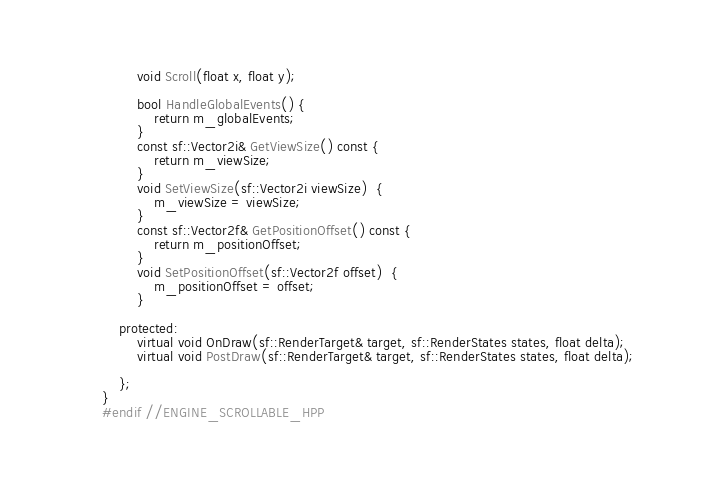<code> <loc_0><loc_0><loc_500><loc_500><_C++_>
		void Scroll(float x, float y);

		bool HandleGlobalEvents() {
			return m_globalEvents;
		}
		const sf::Vector2i& GetViewSize() const {
			return m_viewSize;
		}
		void SetViewSize(sf::Vector2i viewSize)  {
			m_viewSize = viewSize;
		}
		const sf::Vector2f& GetPositionOffset() const {
			return m_positionOffset;
		}
		void SetPositionOffset(sf::Vector2f offset)  {
			m_positionOffset = offset;
		}

	protected:
		virtual void OnDraw(sf::RenderTarget& target, sf::RenderStates states, float delta);
		virtual void PostDraw(sf::RenderTarget& target, sf::RenderStates states, float delta);

	};
}
#endif //ENGINE_SCROLLABLE_HPP
</code> 